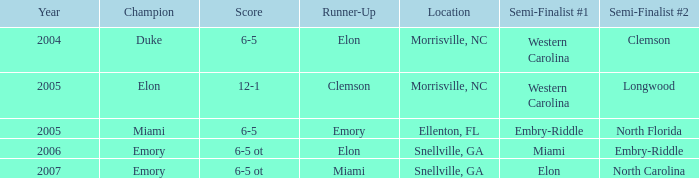How many teams were listed as runner up in 2005 and there the first semi finalist was Western Carolina? 1.0. 